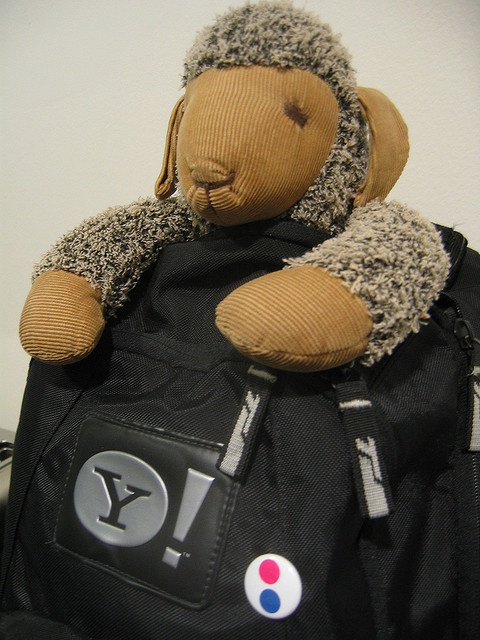Describe the objects in this image and their specific colors. I can see a backpack in black, darkgray, tan, gray, and olive tones in this image. 